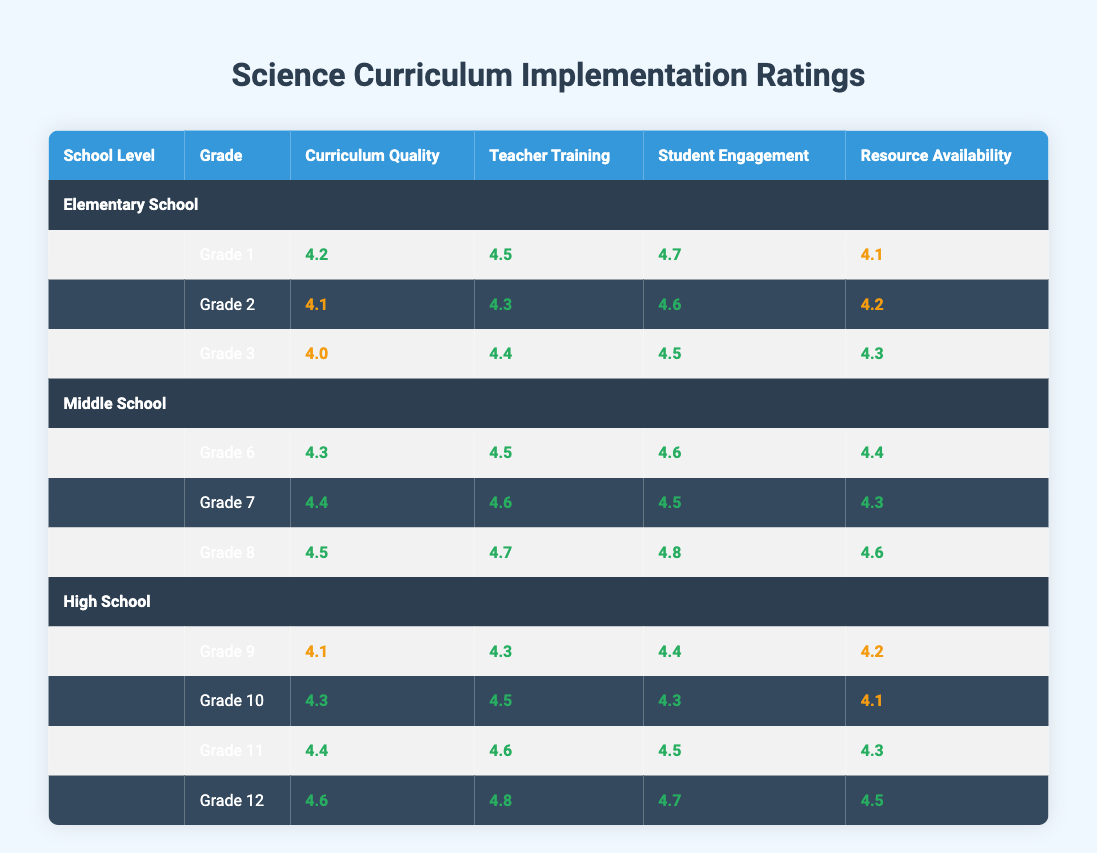What is the Curriculum Quality rating for Grade 1? The table shows that the Curriculum Quality rating for Grade 1 is 4.2. This value can be found directly under the corresponding heading for Grade 1 in the Elementary School section.
Answer: 4.2 Which grade has the highest Teacher Training rating in Middle School? In the Middle School section, I look at the Teacher Training ratings for Grades 6, 7, and 8. The ratings are 4.5 for Grade 6, 4.6 for Grade 7, and 4.7 for Grade 8. The highest rating is 4.7, which corresponds to Grade 8.
Answer: Grade 8 What is the average Student Engagement rating for High School grades? I calculate the average by adding the Student Engagement ratings for Grades 9, 10, 11, and 12, which are 4.4, 4.3, 4.5, and 4.7 respectively. The total is 4.4 + 4.3 + 4.5 + 4.7 = 17.9. Then, I divide by the number of grades, which is 4. Thus, the average is 17.9 / 4 = 4.475.
Answer: 4.475 Is the Resource Availability rating for Grade 10 higher than that for Grade 9? I check the Resource Availability ratings: Grade 10 has a rating of 4.1, and Grade 9 has a rating of 4.2. Since 4.1 is less than 4.2, the statement is false.
Answer: No What is the difference in Curriculum Quality ratings between Grade 3 and Grade 8? I look at the ratings: Grade 3 has a Curriculum Quality rating of 4.0, whereas Grade 8 has a rating of 4.5. The difference is calculated by subtracting Grade 3's rating from Grade 8's: 4.5 - 4.0 = 0.5.
Answer: 0.5 Which grade in High School has the lowest Resource Availability rating? I compare the Resource Availability ratings for Grades 9 to 12. The ratings are 4.2 (Grade 9), 4.1 (Grade 10), 4.3 (Grade 11), and 4.5 (Grade 12). The lowest value is 4.1, which belongs to Grade 10.
Answer: Grade 10 Does Grade 7 have higher Student Engagement than Grade 6? I compare the Student Engagement ratings for both grades: Grade 6 has a rating of 4.6, while Grade 7 has a rating of 4.5. Since 4.5 is less than 4.6, the statement is false.
Answer: No What is the median Teacher Training rating for all grades? I list the Teacher Training ratings: 4.5 (Grade 1), 4.3 (Grade 2), 4.4 (Grade 3), 4.5 (Grade 6), 4.6 (Grade 7), 4.7 (Grade 8), 4.3 (Grade 9), 4.5 (Grade 10), 4.6 (Grade 11), 4.8 (Grade 12). The sorted ratings are 4.3, 4.3, 4.4, 4.5, 4.5, 4.5, 4.6, 4.6, 4.7, 4.8. With 10 ratings, the median is the average of the 5th and 6th values: (4.5 + 4.5) / 2 = 4.5.
Answer: 4.5 